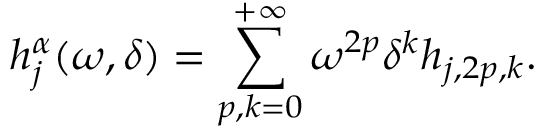Convert formula to latex. <formula><loc_0><loc_0><loc_500><loc_500>h _ { j } ^ { \alpha } ( \omega , \delta ) = \sum _ { p , k = 0 } ^ { + \infty } \omega ^ { 2 p } \delta ^ { k } h _ { j , 2 p , k } .</formula> 